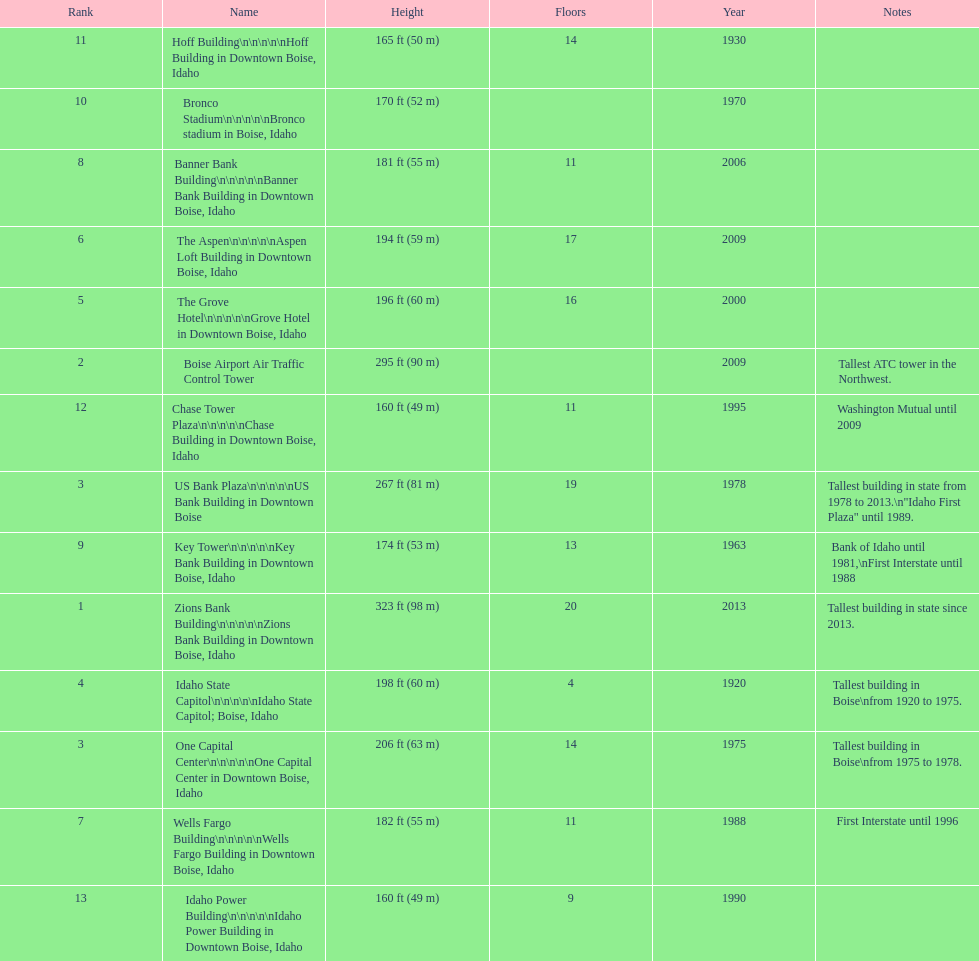What are the number of floors the us bank plaza has? 19. 